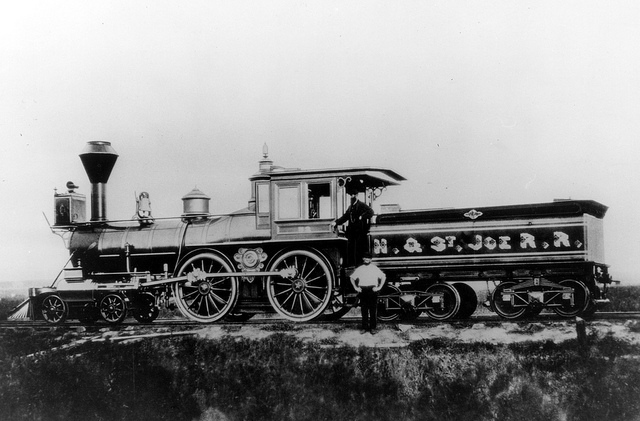Please transcribe the text in this image. 3T Jor R 